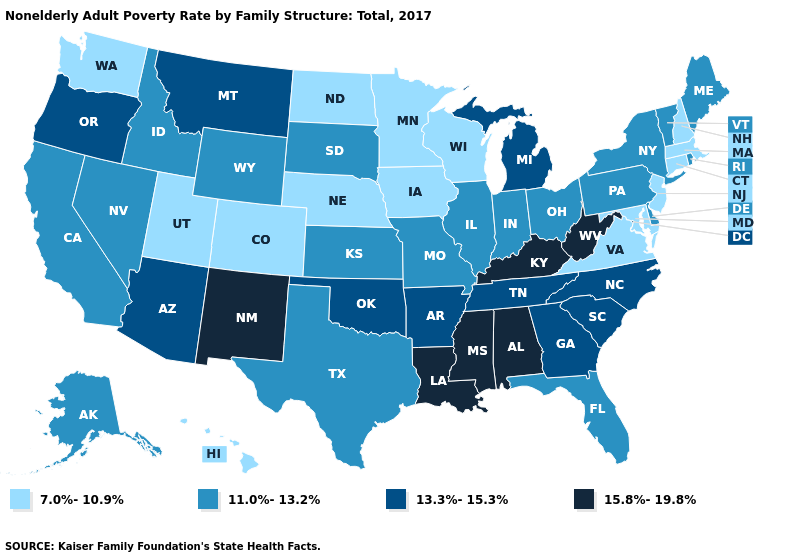Does the map have missing data?
Be succinct. No. What is the value of New Jersey?
Keep it brief. 7.0%-10.9%. Name the states that have a value in the range 11.0%-13.2%?
Answer briefly. Alaska, California, Delaware, Florida, Idaho, Illinois, Indiana, Kansas, Maine, Missouri, Nevada, New York, Ohio, Pennsylvania, Rhode Island, South Dakota, Texas, Vermont, Wyoming. Which states have the lowest value in the USA?
Keep it brief. Colorado, Connecticut, Hawaii, Iowa, Maryland, Massachusetts, Minnesota, Nebraska, New Hampshire, New Jersey, North Dakota, Utah, Virginia, Washington, Wisconsin. Is the legend a continuous bar?
Give a very brief answer. No. What is the value of Arizona?
Concise answer only. 13.3%-15.3%. Which states have the lowest value in the USA?
Answer briefly. Colorado, Connecticut, Hawaii, Iowa, Maryland, Massachusetts, Minnesota, Nebraska, New Hampshire, New Jersey, North Dakota, Utah, Virginia, Washington, Wisconsin. Name the states that have a value in the range 15.8%-19.8%?
Be succinct. Alabama, Kentucky, Louisiana, Mississippi, New Mexico, West Virginia. What is the value of South Carolina?
Answer briefly. 13.3%-15.3%. Which states have the lowest value in the USA?
Quick response, please. Colorado, Connecticut, Hawaii, Iowa, Maryland, Massachusetts, Minnesota, Nebraska, New Hampshire, New Jersey, North Dakota, Utah, Virginia, Washington, Wisconsin. Which states have the highest value in the USA?
Write a very short answer. Alabama, Kentucky, Louisiana, Mississippi, New Mexico, West Virginia. Among the states that border New Mexico , which have the lowest value?
Short answer required. Colorado, Utah. Which states have the lowest value in the USA?
Answer briefly. Colorado, Connecticut, Hawaii, Iowa, Maryland, Massachusetts, Minnesota, Nebraska, New Hampshire, New Jersey, North Dakota, Utah, Virginia, Washington, Wisconsin. Name the states that have a value in the range 7.0%-10.9%?
Keep it brief. Colorado, Connecticut, Hawaii, Iowa, Maryland, Massachusetts, Minnesota, Nebraska, New Hampshire, New Jersey, North Dakota, Utah, Virginia, Washington, Wisconsin. 